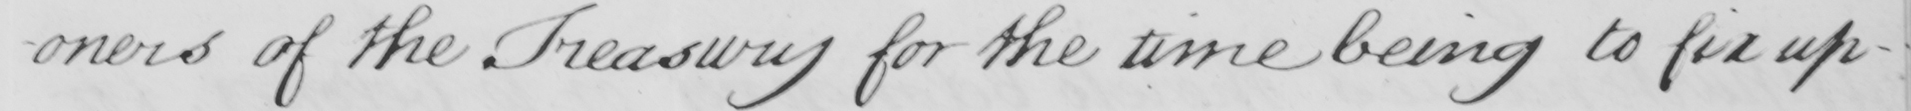What is written in this line of handwriting? -oners of the Treasury for the time being to fix up- 